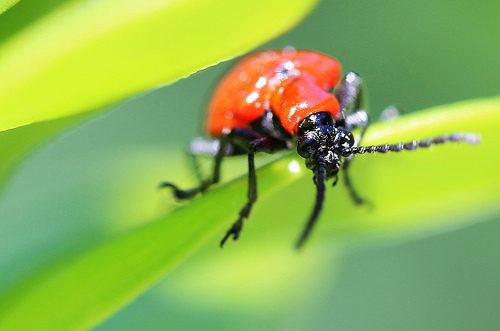<image>
Is there a insect on the leaf? Yes. Looking at the image, I can see the insect is positioned on top of the leaf, with the leaf providing support. 